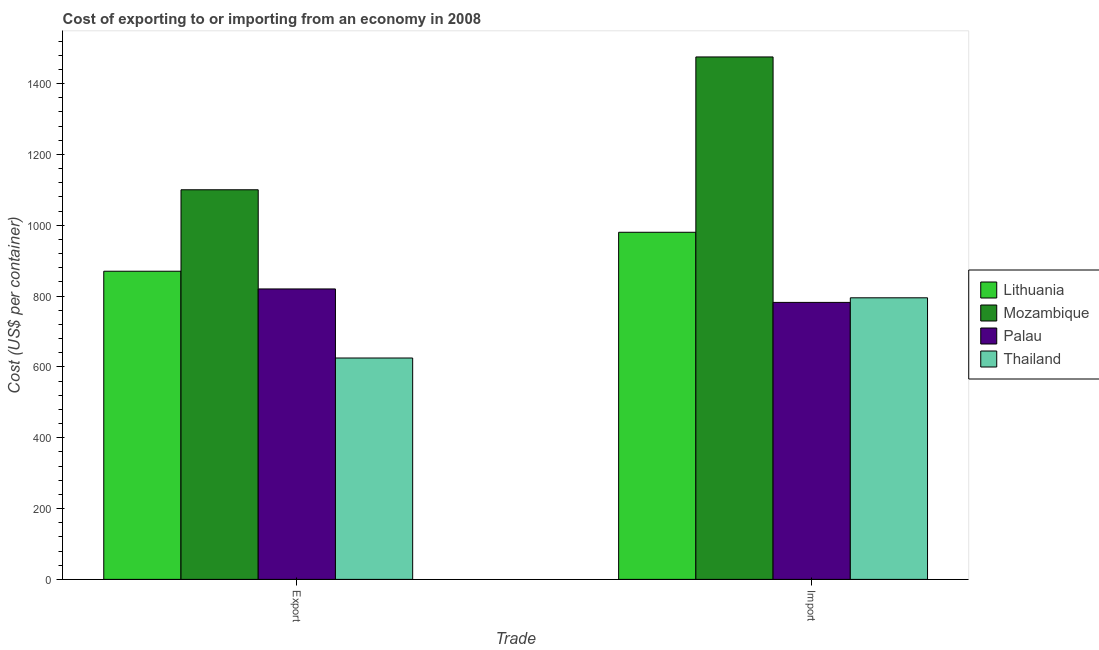Are the number of bars per tick equal to the number of legend labels?
Your response must be concise. Yes. Are the number of bars on each tick of the X-axis equal?
Ensure brevity in your answer.  Yes. How many bars are there on the 1st tick from the left?
Provide a short and direct response. 4. What is the label of the 1st group of bars from the left?
Your response must be concise. Export. What is the import cost in Lithuania?
Your answer should be compact. 980. Across all countries, what is the maximum import cost?
Provide a succinct answer. 1475. Across all countries, what is the minimum export cost?
Your response must be concise. 625. In which country was the export cost maximum?
Give a very brief answer. Mozambique. In which country was the export cost minimum?
Your answer should be very brief. Thailand. What is the total export cost in the graph?
Provide a succinct answer. 3415. What is the difference between the import cost in Thailand and that in Lithuania?
Your answer should be compact. -185. What is the difference between the export cost in Lithuania and the import cost in Mozambique?
Make the answer very short. -605. What is the average export cost per country?
Provide a succinct answer. 853.75. What is the difference between the export cost and import cost in Thailand?
Keep it short and to the point. -170. What is the ratio of the export cost in Mozambique to that in Thailand?
Provide a succinct answer. 1.76. Is the export cost in Mozambique less than that in Thailand?
Give a very brief answer. No. What does the 4th bar from the left in Import represents?
Provide a short and direct response. Thailand. What does the 3rd bar from the right in Import represents?
Provide a succinct answer. Mozambique. Are all the bars in the graph horizontal?
Your answer should be very brief. No. How many countries are there in the graph?
Offer a terse response. 4. Does the graph contain any zero values?
Offer a very short reply. No. Does the graph contain grids?
Your answer should be very brief. No. Where does the legend appear in the graph?
Your answer should be compact. Center right. How are the legend labels stacked?
Offer a very short reply. Vertical. What is the title of the graph?
Your answer should be very brief. Cost of exporting to or importing from an economy in 2008. Does "Haiti" appear as one of the legend labels in the graph?
Ensure brevity in your answer.  No. What is the label or title of the X-axis?
Provide a succinct answer. Trade. What is the label or title of the Y-axis?
Keep it short and to the point. Cost (US$ per container). What is the Cost (US$ per container) of Lithuania in Export?
Give a very brief answer. 870. What is the Cost (US$ per container) in Mozambique in Export?
Make the answer very short. 1100. What is the Cost (US$ per container) in Palau in Export?
Make the answer very short. 820. What is the Cost (US$ per container) in Thailand in Export?
Offer a very short reply. 625. What is the Cost (US$ per container) of Lithuania in Import?
Your answer should be compact. 980. What is the Cost (US$ per container) of Mozambique in Import?
Keep it short and to the point. 1475. What is the Cost (US$ per container) of Palau in Import?
Your answer should be very brief. 782. What is the Cost (US$ per container) in Thailand in Import?
Provide a short and direct response. 795. Across all Trade, what is the maximum Cost (US$ per container) of Lithuania?
Keep it short and to the point. 980. Across all Trade, what is the maximum Cost (US$ per container) of Mozambique?
Offer a terse response. 1475. Across all Trade, what is the maximum Cost (US$ per container) in Palau?
Provide a short and direct response. 820. Across all Trade, what is the maximum Cost (US$ per container) of Thailand?
Your answer should be very brief. 795. Across all Trade, what is the minimum Cost (US$ per container) in Lithuania?
Provide a short and direct response. 870. Across all Trade, what is the minimum Cost (US$ per container) in Mozambique?
Make the answer very short. 1100. Across all Trade, what is the minimum Cost (US$ per container) in Palau?
Provide a succinct answer. 782. Across all Trade, what is the minimum Cost (US$ per container) in Thailand?
Ensure brevity in your answer.  625. What is the total Cost (US$ per container) of Lithuania in the graph?
Give a very brief answer. 1850. What is the total Cost (US$ per container) of Mozambique in the graph?
Keep it short and to the point. 2575. What is the total Cost (US$ per container) of Palau in the graph?
Offer a terse response. 1602. What is the total Cost (US$ per container) of Thailand in the graph?
Your response must be concise. 1420. What is the difference between the Cost (US$ per container) of Lithuania in Export and that in Import?
Keep it short and to the point. -110. What is the difference between the Cost (US$ per container) of Mozambique in Export and that in Import?
Provide a short and direct response. -375. What is the difference between the Cost (US$ per container) in Palau in Export and that in Import?
Provide a short and direct response. 38. What is the difference between the Cost (US$ per container) of Thailand in Export and that in Import?
Keep it short and to the point. -170. What is the difference between the Cost (US$ per container) of Lithuania in Export and the Cost (US$ per container) of Mozambique in Import?
Offer a very short reply. -605. What is the difference between the Cost (US$ per container) in Mozambique in Export and the Cost (US$ per container) in Palau in Import?
Provide a succinct answer. 318. What is the difference between the Cost (US$ per container) of Mozambique in Export and the Cost (US$ per container) of Thailand in Import?
Offer a terse response. 305. What is the average Cost (US$ per container) of Lithuania per Trade?
Keep it short and to the point. 925. What is the average Cost (US$ per container) of Mozambique per Trade?
Give a very brief answer. 1287.5. What is the average Cost (US$ per container) in Palau per Trade?
Your response must be concise. 801. What is the average Cost (US$ per container) of Thailand per Trade?
Provide a succinct answer. 710. What is the difference between the Cost (US$ per container) of Lithuania and Cost (US$ per container) of Mozambique in Export?
Keep it short and to the point. -230. What is the difference between the Cost (US$ per container) in Lithuania and Cost (US$ per container) in Palau in Export?
Your answer should be compact. 50. What is the difference between the Cost (US$ per container) in Lithuania and Cost (US$ per container) in Thailand in Export?
Your answer should be very brief. 245. What is the difference between the Cost (US$ per container) in Mozambique and Cost (US$ per container) in Palau in Export?
Your answer should be compact. 280. What is the difference between the Cost (US$ per container) in Mozambique and Cost (US$ per container) in Thailand in Export?
Offer a very short reply. 475. What is the difference between the Cost (US$ per container) of Palau and Cost (US$ per container) of Thailand in Export?
Give a very brief answer. 195. What is the difference between the Cost (US$ per container) in Lithuania and Cost (US$ per container) in Mozambique in Import?
Offer a very short reply. -495. What is the difference between the Cost (US$ per container) in Lithuania and Cost (US$ per container) in Palau in Import?
Provide a succinct answer. 198. What is the difference between the Cost (US$ per container) of Lithuania and Cost (US$ per container) of Thailand in Import?
Give a very brief answer. 185. What is the difference between the Cost (US$ per container) of Mozambique and Cost (US$ per container) of Palau in Import?
Provide a short and direct response. 693. What is the difference between the Cost (US$ per container) of Mozambique and Cost (US$ per container) of Thailand in Import?
Keep it short and to the point. 680. What is the difference between the Cost (US$ per container) of Palau and Cost (US$ per container) of Thailand in Import?
Provide a short and direct response. -13. What is the ratio of the Cost (US$ per container) in Lithuania in Export to that in Import?
Keep it short and to the point. 0.89. What is the ratio of the Cost (US$ per container) in Mozambique in Export to that in Import?
Provide a succinct answer. 0.75. What is the ratio of the Cost (US$ per container) of Palau in Export to that in Import?
Provide a succinct answer. 1.05. What is the ratio of the Cost (US$ per container) in Thailand in Export to that in Import?
Provide a short and direct response. 0.79. What is the difference between the highest and the second highest Cost (US$ per container) in Lithuania?
Make the answer very short. 110. What is the difference between the highest and the second highest Cost (US$ per container) in Mozambique?
Offer a very short reply. 375. What is the difference between the highest and the second highest Cost (US$ per container) in Thailand?
Your answer should be very brief. 170. What is the difference between the highest and the lowest Cost (US$ per container) of Lithuania?
Give a very brief answer. 110. What is the difference between the highest and the lowest Cost (US$ per container) of Mozambique?
Offer a terse response. 375. What is the difference between the highest and the lowest Cost (US$ per container) of Palau?
Provide a short and direct response. 38. What is the difference between the highest and the lowest Cost (US$ per container) in Thailand?
Keep it short and to the point. 170. 